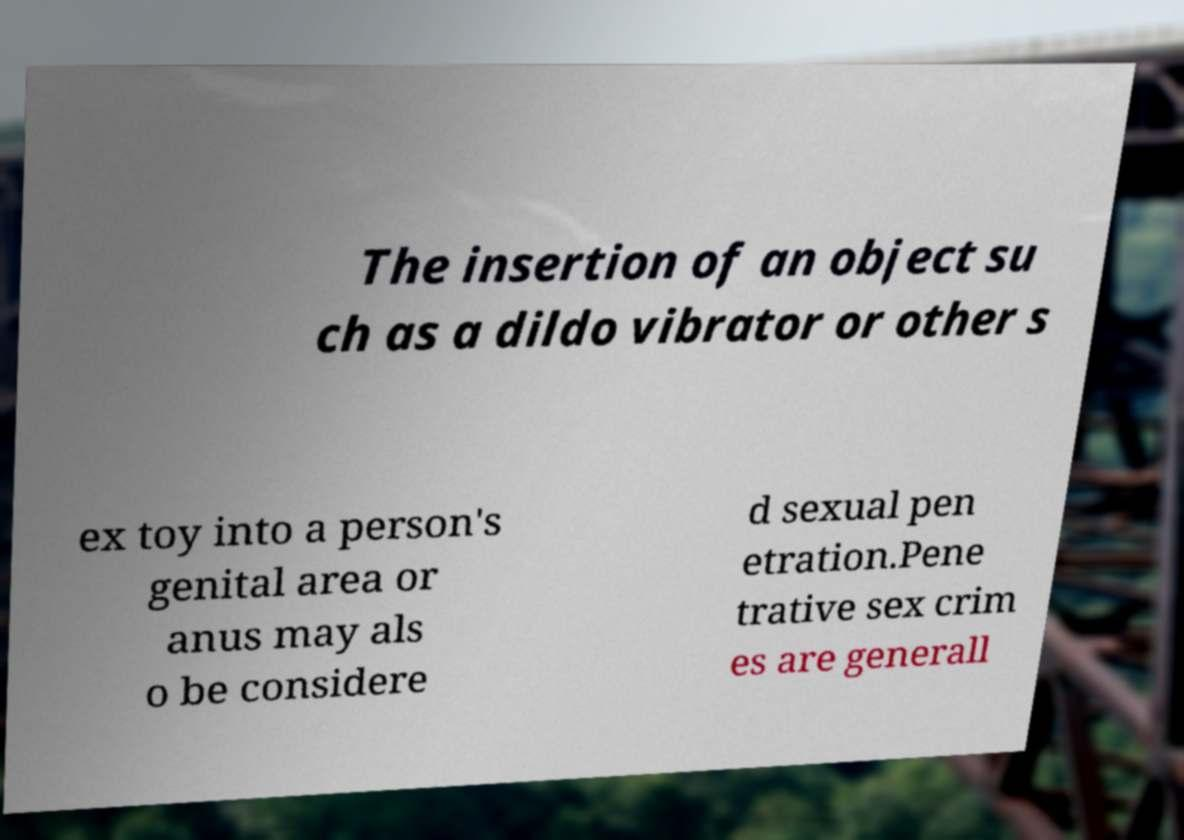Could you extract and type out the text from this image? The insertion of an object su ch as a dildo vibrator or other s ex toy into a person's genital area or anus may als o be considere d sexual pen etration.Pene trative sex crim es are generall 